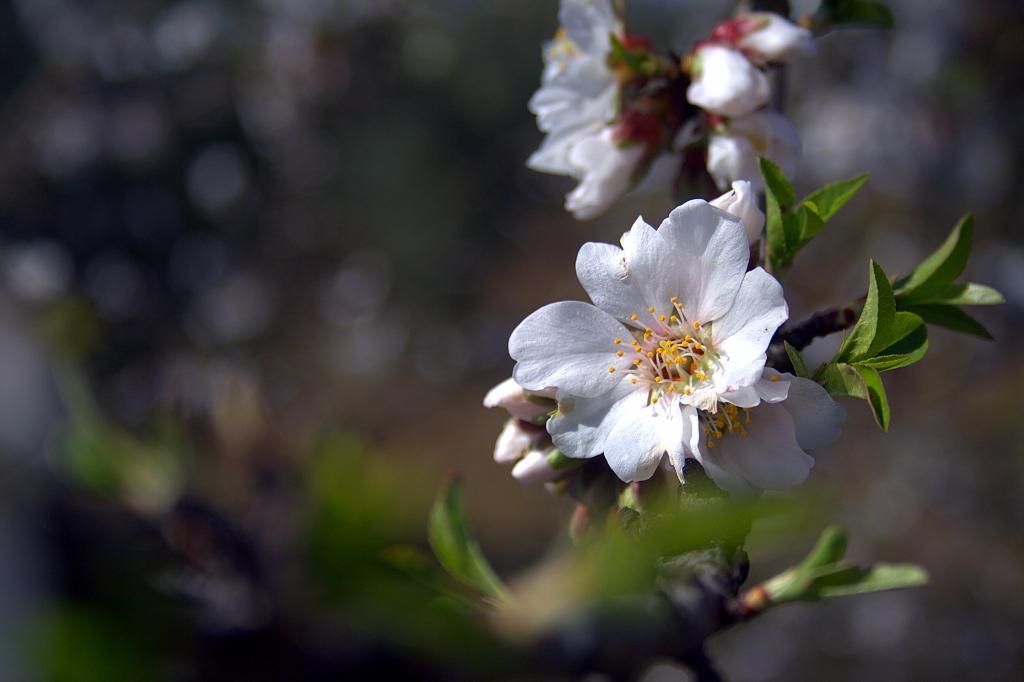In one or two sentences, can you explain what this image depicts? In this image there is a tree truncated, there are flowers on the tree, the background of the image is blurred. 